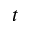Convert formula to latex. <formula><loc_0><loc_0><loc_500><loc_500>t</formula> 